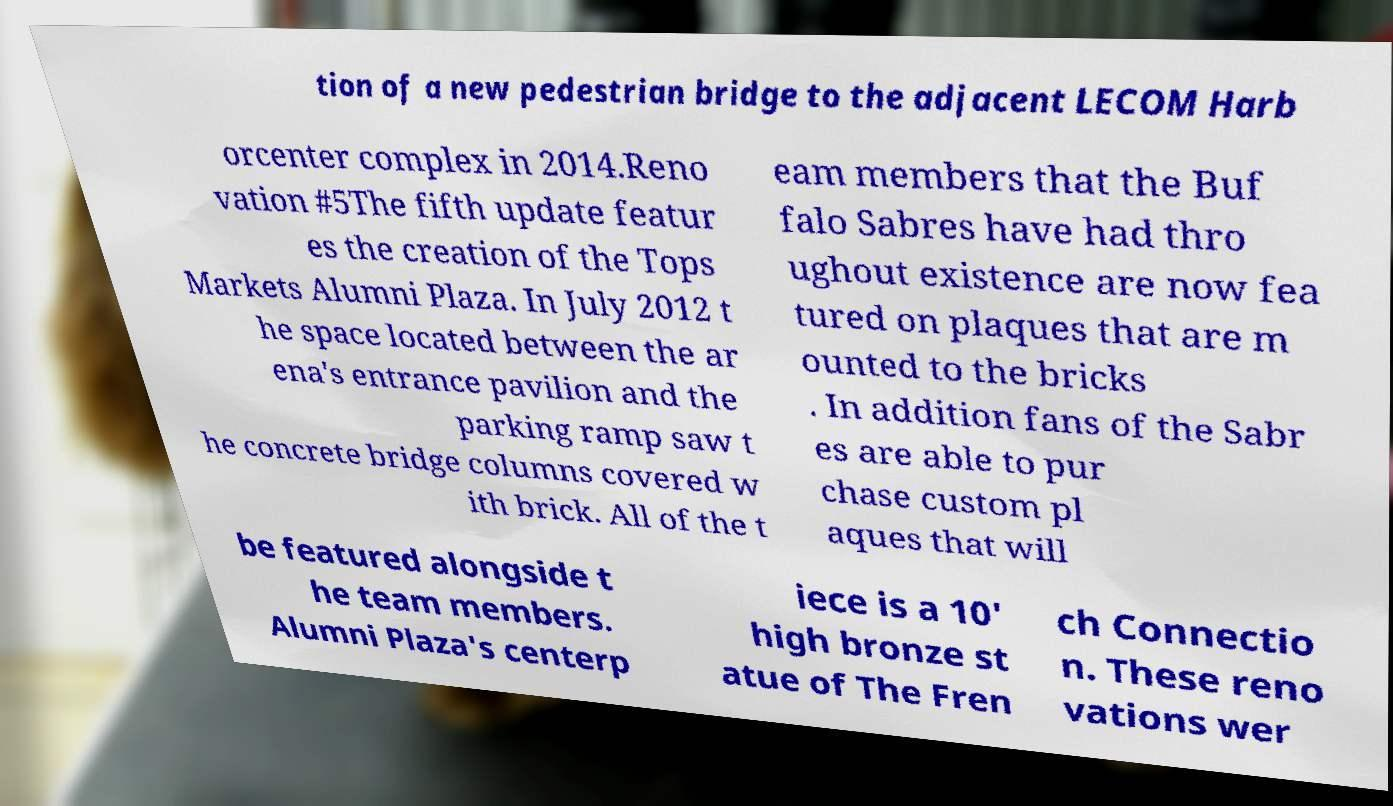Please read and relay the text visible in this image. What does it say? tion of a new pedestrian bridge to the adjacent LECOM Harb orcenter complex in 2014.Reno vation #5The fifth update featur es the creation of the Tops Markets Alumni Plaza. In July 2012 t he space located between the ar ena's entrance pavilion and the parking ramp saw t he concrete bridge columns covered w ith brick. All of the t eam members that the Buf falo Sabres have had thro ughout existence are now fea tured on plaques that are m ounted to the bricks . In addition fans of the Sabr es are able to pur chase custom pl aques that will be featured alongside t he team members. Alumni Plaza's centerp iece is a 10' high bronze st atue of The Fren ch Connectio n. These reno vations wer 